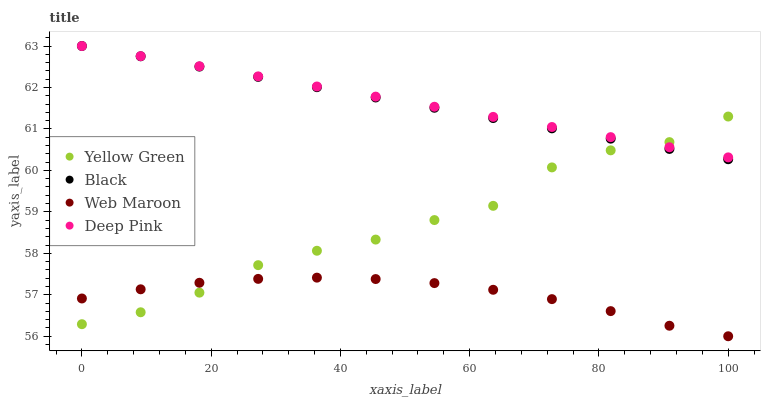Does Web Maroon have the minimum area under the curve?
Answer yes or no. Yes. Does Deep Pink have the maximum area under the curve?
Answer yes or no. Yes. Does Black have the minimum area under the curve?
Answer yes or no. No. Does Black have the maximum area under the curve?
Answer yes or no. No. Is Black the smoothest?
Answer yes or no. Yes. Is Yellow Green the roughest?
Answer yes or no. Yes. Is Deep Pink the smoothest?
Answer yes or no. No. Is Deep Pink the roughest?
Answer yes or no. No. Does Web Maroon have the lowest value?
Answer yes or no. Yes. Does Black have the lowest value?
Answer yes or no. No. Does Black have the highest value?
Answer yes or no. Yes. Does Yellow Green have the highest value?
Answer yes or no. No. Is Web Maroon less than Black?
Answer yes or no. Yes. Is Deep Pink greater than Web Maroon?
Answer yes or no. Yes. Does Black intersect Deep Pink?
Answer yes or no. Yes. Is Black less than Deep Pink?
Answer yes or no. No. Is Black greater than Deep Pink?
Answer yes or no. No. Does Web Maroon intersect Black?
Answer yes or no. No. 